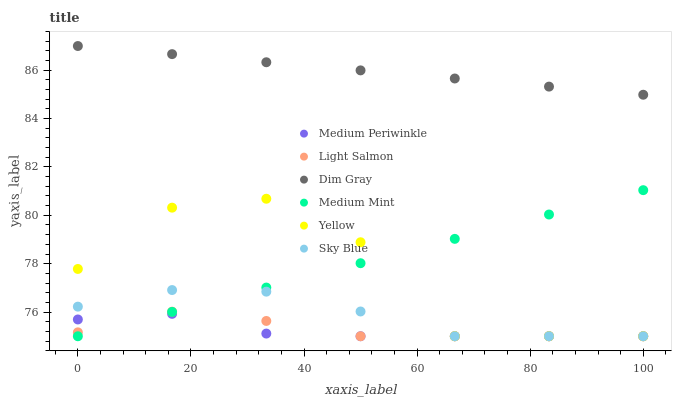Does Medium Periwinkle have the minimum area under the curve?
Answer yes or no. Yes. Does Dim Gray have the maximum area under the curve?
Answer yes or no. Yes. Does Light Salmon have the minimum area under the curve?
Answer yes or no. No. Does Light Salmon have the maximum area under the curve?
Answer yes or no. No. Is Medium Mint the smoothest?
Answer yes or no. Yes. Is Yellow the roughest?
Answer yes or no. Yes. Is Light Salmon the smoothest?
Answer yes or no. No. Is Light Salmon the roughest?
Answer yes or no. No. Does Medium Mint have the lowest value?
Answer yes or no. Yes. Does Dim Gray have the lowest value?
Answer yes or no. No. Does Dim Gray have the highest value?
Answer yes or no. Yes. Does Light Salmon have the highest value?
Answer yes or no. No. Is Yellow less than Dim Gray?
Answer yes or no. Yes. Is Dim Gray greater than Yellow?
Answer yes or no. Yes. Does Medium Mint intersect Medium Periwinkle?
Answer yes or no. Yes. Is Medium Mint less than Medium Periwinkle?
Answer yes or no. No. Is Medium Mint greater than Medium Periwinkle?
Answer yes or no. No. Does Yellow intersect Dim Gray?
Answer yes or no. No. 